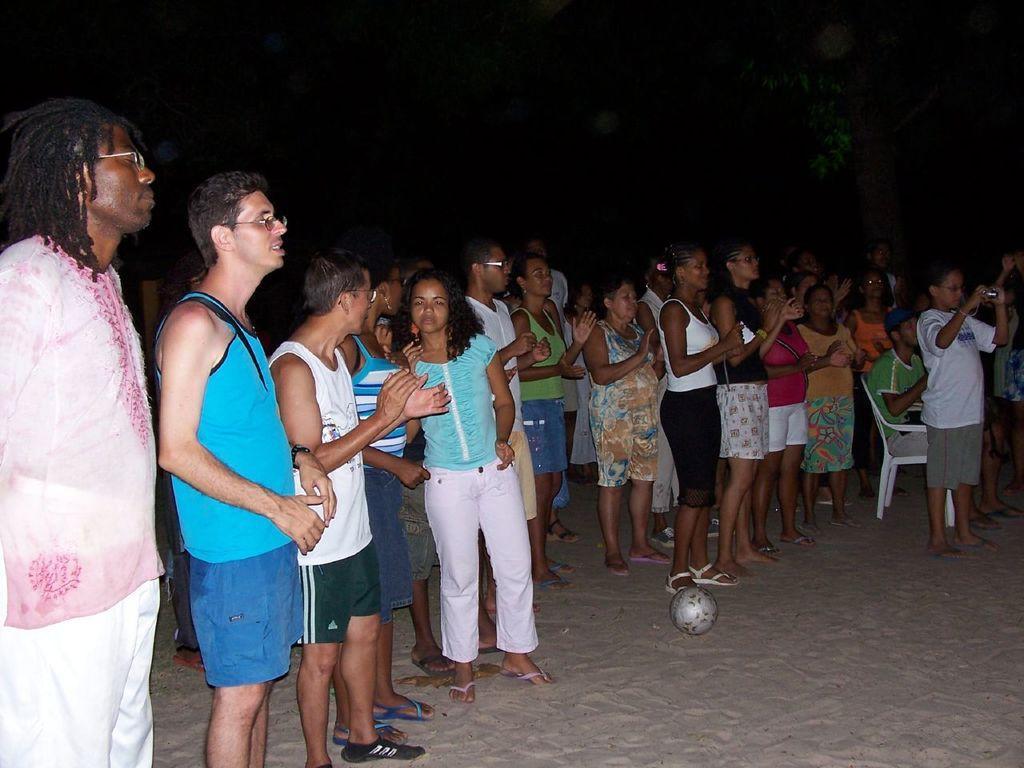Can you describe this image briefly? This picture shows few people standing and a man seated on the chair and we see a boy standing and holding a camera in his hand and we see a ball on the ground and we see a tree and few of them were spectacles on their faces. 